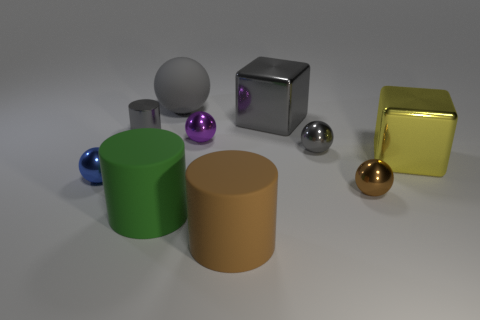What number of metal objects are right of the big brown matte object and behind the large yellow block?
Offer a terse response. 2. Is the big gray sphere made of the same material as the tiny object in front of the blue metallic sphere?
Offer a very short reply. No. Is the number of gray rubber objects that are behind the tiny gray cylinder the same as the number of purple objects?
Provide a short and direct response. Yes. What color is the cylinder to the right of the green thing?
Offer a very short reply. Brown. How many other objects are the same color as the shiny cylinder?
Your response must be concise. 3. Is there anything else that is the same size as the blue sphere?
Your answer should be compact. Yes. Is the size of the shiny cube in front of the metal cylinder the same as the brown rubber cylinder?
Give a very brief answer. Yes. What is the material of the cylinder behind the purple shiny ball?
Your answer should be very brief. Metal. Is there anything else that is the same shape as the big green object?
Your response must be concise. Yes. How many rubber objects are tiny spheres or tiny blue balls?
Ensure brevity in your answer.  0. 